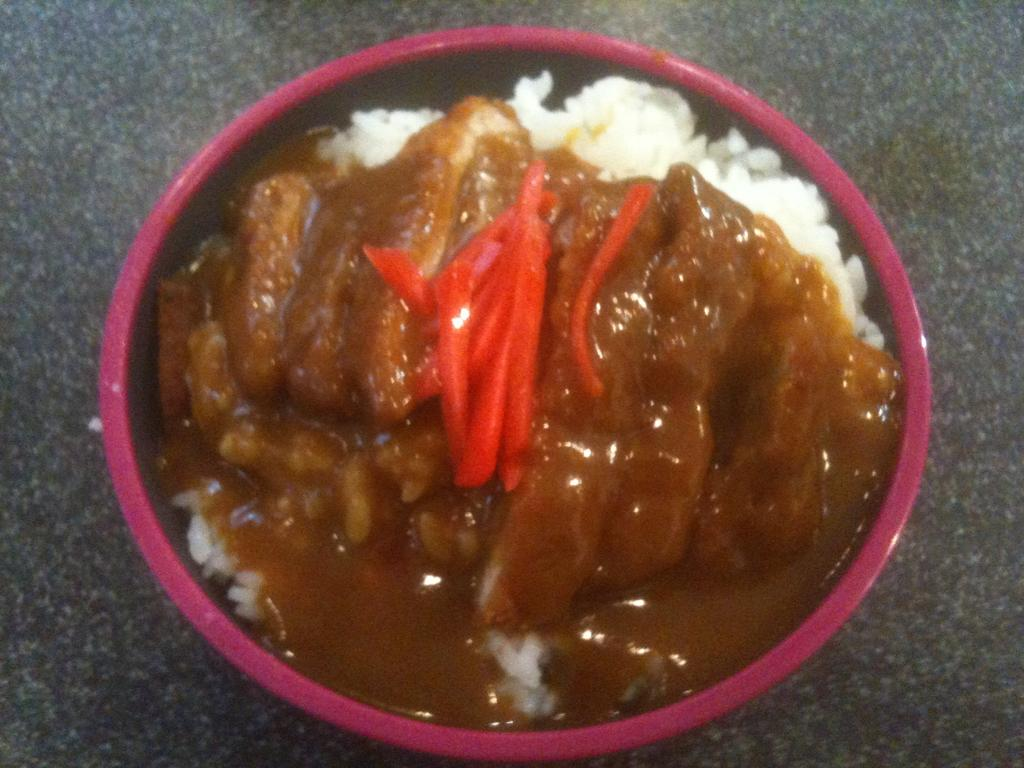What is located in the center of the image? There is a bowl in the center of the image. What is inside the bowl? The bowl contains food. What part of the room can be seen at the bottom of the image? The floor is visible at the bottom of the image. How does the liquid drain from the bowl in the image? There is no liquid present in the image, and therefore no draining from the bowl. 